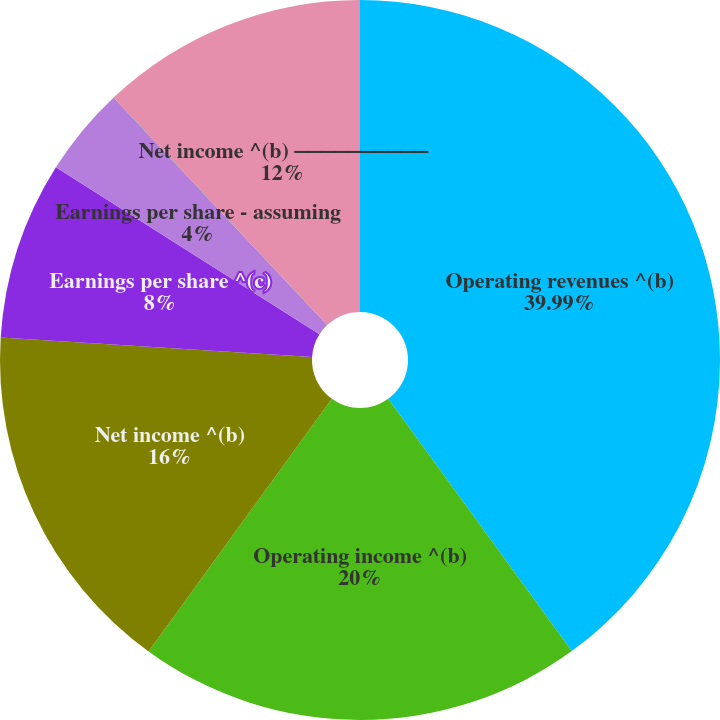Convert chart. <chart><loc_0><loc_0><loc_500><loc_500><pie_chart><fcel>Operating revenues ^(b)<fcel>Operating income ^(b)<fcel>Net income ^(b)<fcel>Earnings per share ^(c)<fcel>Earnings per share - assuming<fcel>Dividends per share<fcel>Net income ^(b) ⎯⎯⎯⎯⎯⎯⎯⎯⎯⎯<nl><fcel>39.99%<fcel>20.0%<fcel>16.0%<fcel>8.0%<fcel>4.0%<fcel>0.01%<fcel>12.0%<nl></chart> 